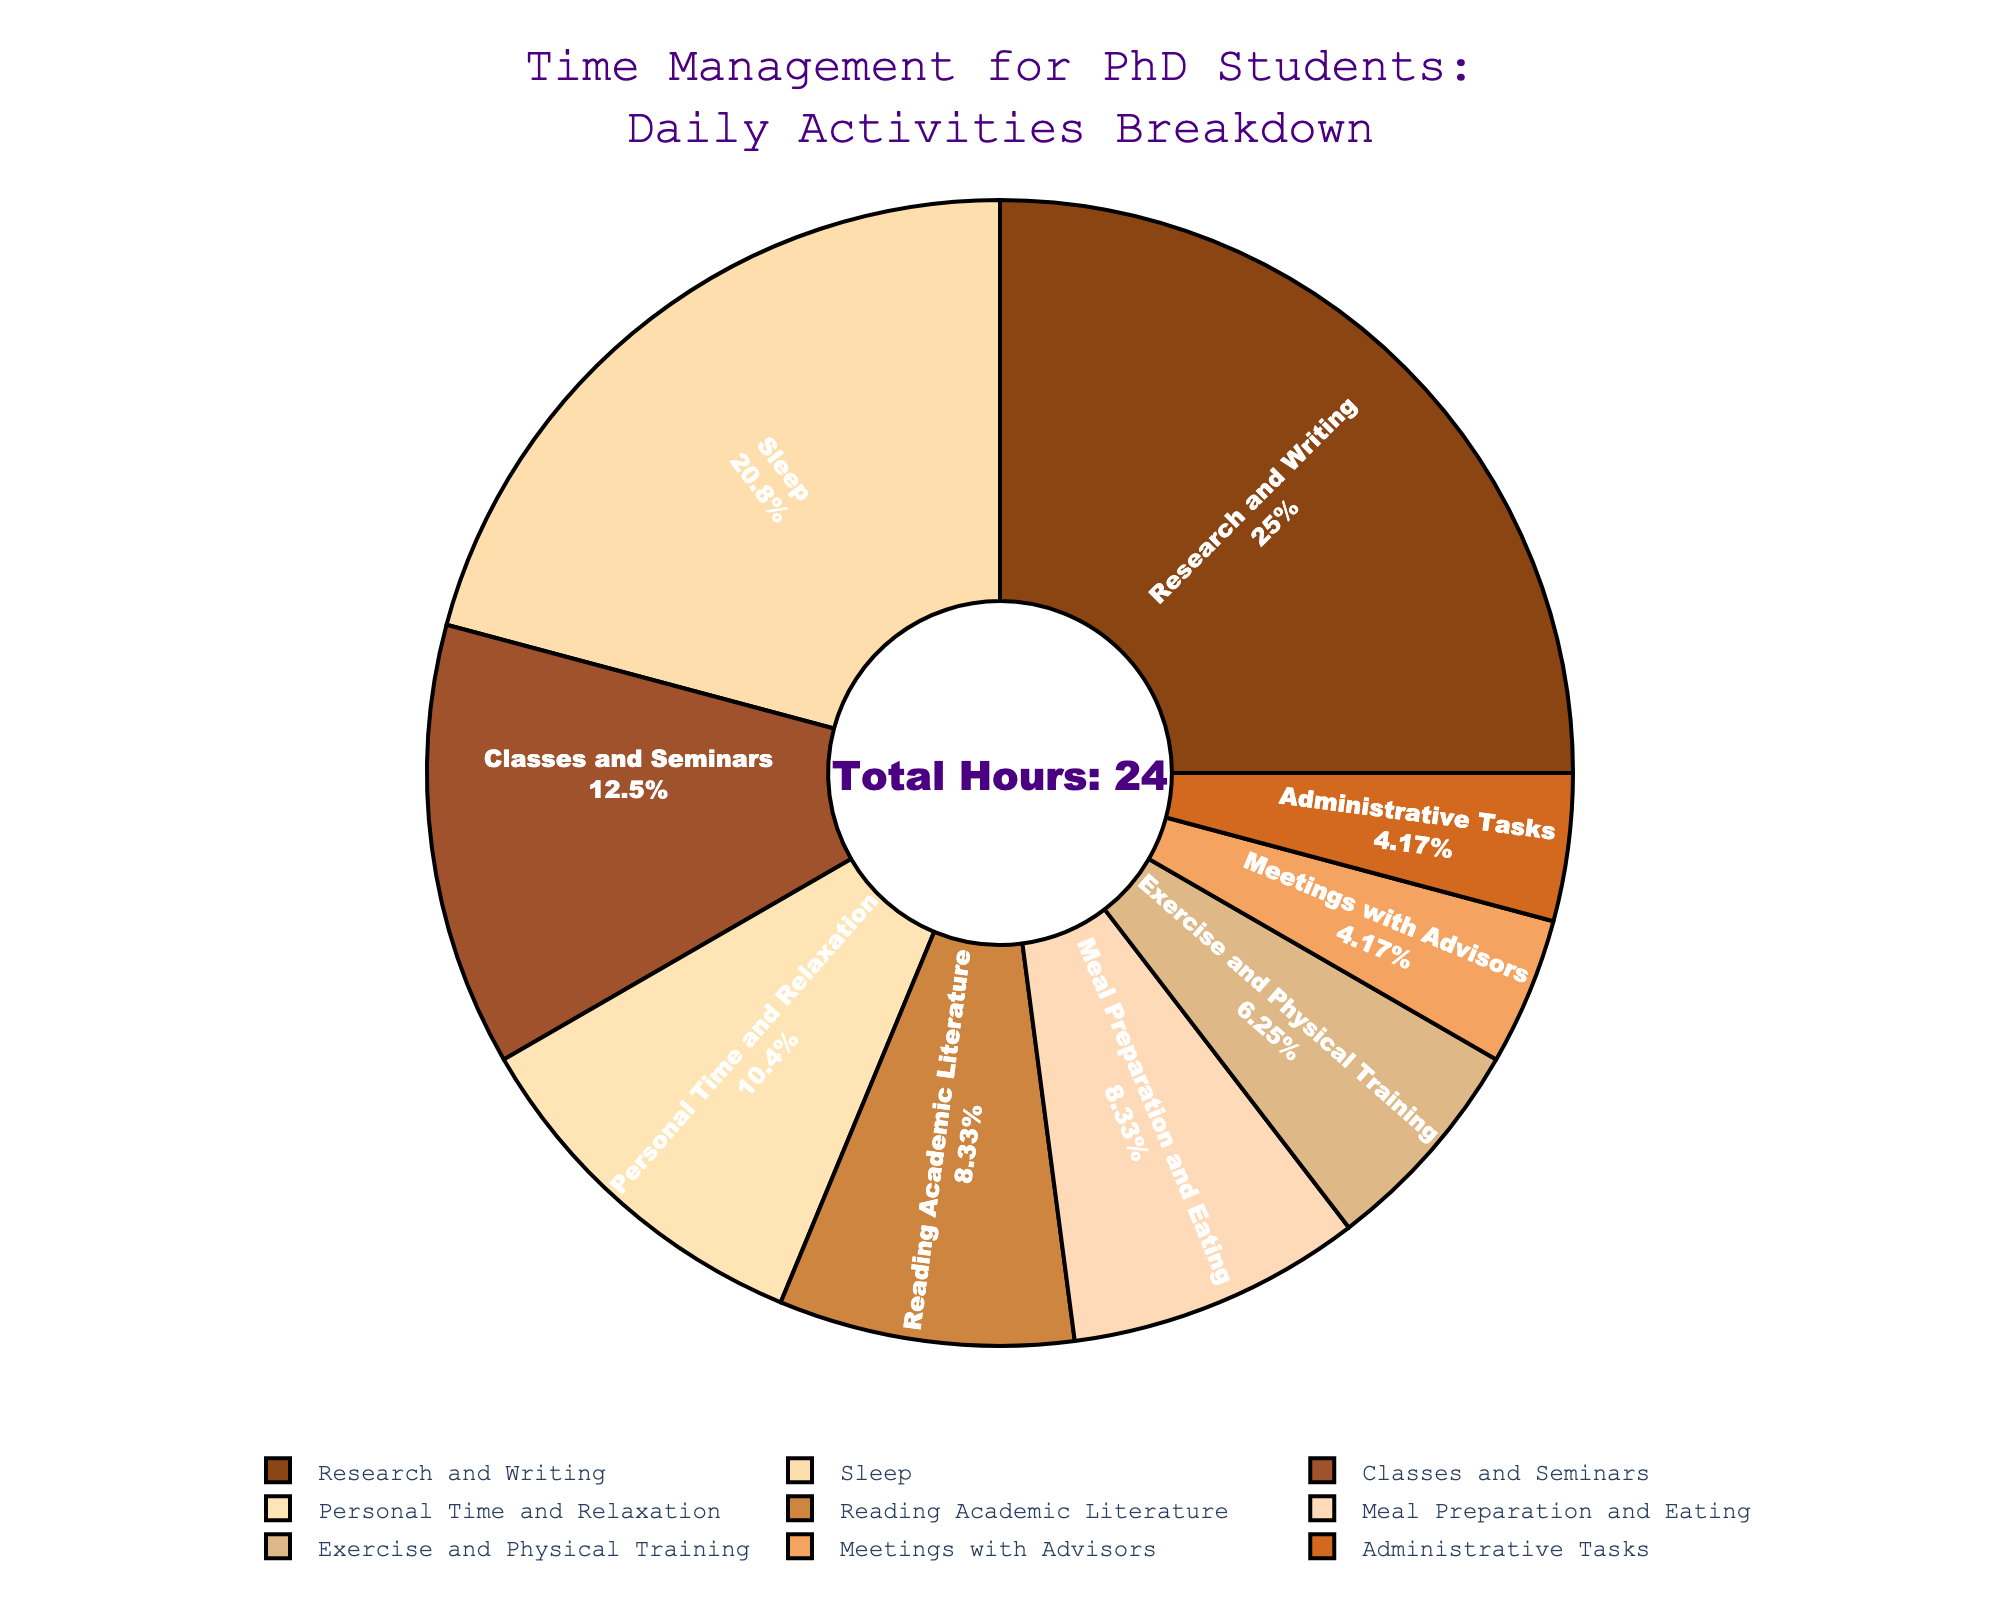What percentage of the day is spent on Research and Writing? Research and Writing occupies a segment of the pie chart. According to the chart's text info, it shows the percentage along with the label. Identify the segment labeled "Research and Writing" and note its percentage value.
Answer: 25% Is more time spent on Exercise and Physical Training or on Meetings with Advisors? Compare the segments labeled "Exercise and Physical Training" (1.5 hours) and "Meetings with Advisors" (1 hour). The size and percentage of the segments can help determine which one is larger.
Answer: Exercise and Physical Training What is the combined percentage of time spent on Meal Preparation and Eating and Personal Time and Relaxation? Find the segments labeled "Meal Preparation and Eating" and "Personal Time and Relaxation". Sum their respective percentages.
Answer: 18.75% Which activity takes up the smallest portion of the pie chart? Identify the smallest segment in the pie chart by comparing the sizes of all segments.
Answer: Administrative Tasks Are more hours spent on Classes and Seminars or on Reading Academic Literature? Compare the hours spent on "Classes and Seminars" (3 hours) and "Reading Academic Literature" (2 hours) by looking at the segment sizes.
Answer: Classes and Seminars What is the total number of hours allocated to Exercise and Physical Training, Meetings with Advisors, and Administrative Tasks combined? Add the hours for "Exercise and Physical Training" (1.5), "Meetings with Advisors" (1), and "Administrative Tasks" (1).
Answer: 3.5 hours Is the time spent on Personal Time and Relaxation more than double the time spent on Administrative Tasks? Compare the hours for "Personal Time and Relaxation" (2.5) to twice the hours for "Administrative Tasks" (2 * 1 hour). 2.5 hours > 2 hours confirm the comparison.
Answer: Yes How many more hours are spent on Research and Writing compared to Sleep? Subtract the hours spent on "Sleep" (5) from the hours spent on "Research and Writing" (6).
Answer: 1 hour Which activity uses the color brown in the chart? Identify the color brown used in the pie chart and match it to the corresponding activity label.
Answer: Research and Writing 